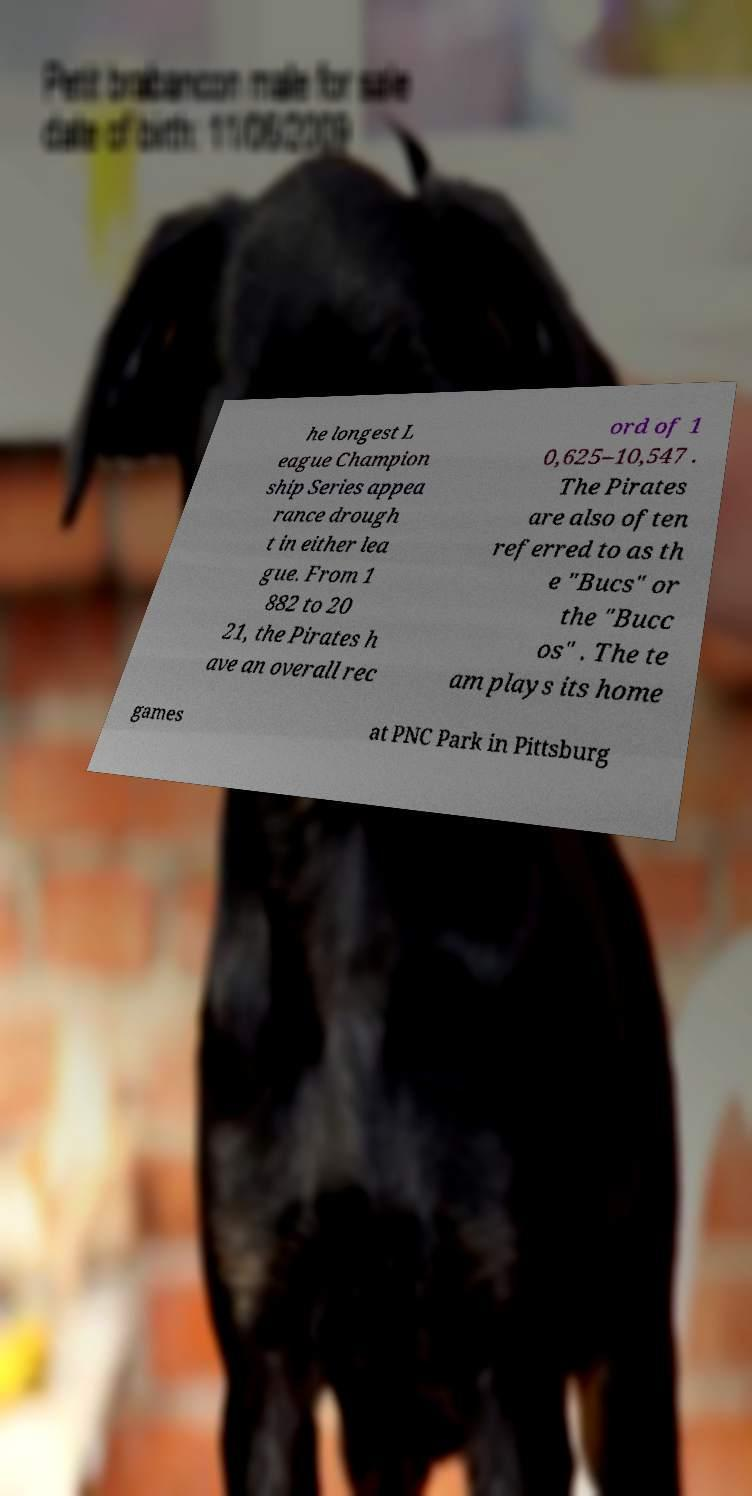Could you assist in decoding the text presented in this image and type it out clearly? he longest L eague Champion ship Series appea rance drough t in either lea gue. From 1 882 to 20 21, the Pirates h ave an overall rec ord of 1 0,625–10,547 . The Pirates are also often referred to as th e "Bucs" or the "Bucc os" . The te am plays its home games at PNC Park in Pittsburg 